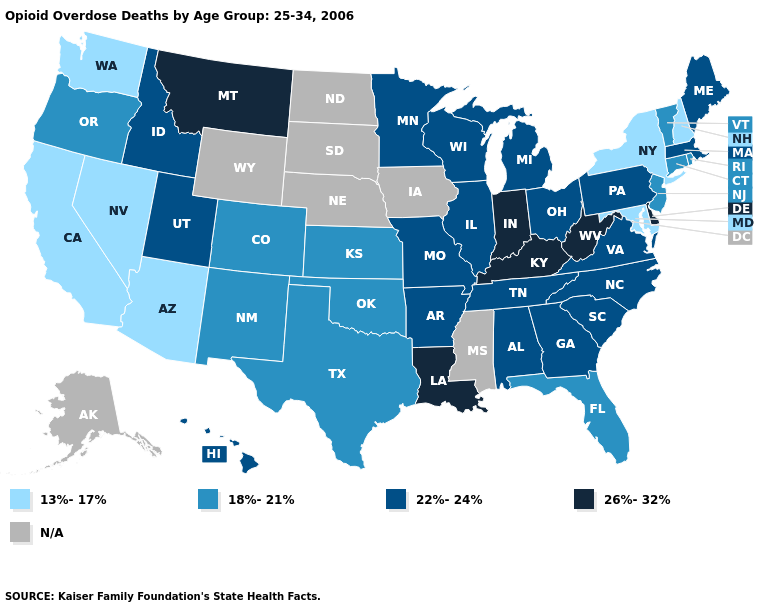Does Montana have the lowest value in the USA?
Quick response, please. No. What is the lowest value in the USA?
Keep it brief. 13%-17%. Does Connecticut have the highest value in the Northeast?
Write a very short answer. No. Name the states that have a value in the range 13%-17%?
Be succinct. Arizona, California, Maryland, Nevada, New Hampshire, New York, Washington. What is the highest value in states that border Nevada?
Quick response, please. 22%-24%. What is the lowest value in states that border West Virginia?
Answer briefly. 13%-17%. Name the states that have a value in the range 18%-21%?
Concise answer only. Colorado, Connecticut, Florida, Kansas, New Jersey, New Mexico, Oklahoma, Oregon, Rhode Island, Texas, Vermont. Which states have the highest value in the USA?
Answer briefly. Delaware, Indiana, Kentucky, Louisiana, Montana, West Virginia. Does Massachusetts have the highest value in the Northeast?
Be succinct. Yes. Does Maryland have the lowest value in the South?
Give a very brief answer. Yes. What is the value of North Carolina?
Quick response, please. 22%-24%. Name the states that have a value in the range 22%-24%?
Quick response, please. Alabama, Arkansas, Georgia, Hawaii, Idaho, Illinois, Maine, Massachusetts, Michigan, Minnesota, Missouri, North Carolina, Ohio, Pennsylvania, South Carolina, Tennessee, Utah, Virginia, Wisconsin. What is the highest value in the USA?
Give a very brief answer. 26%-32%. 